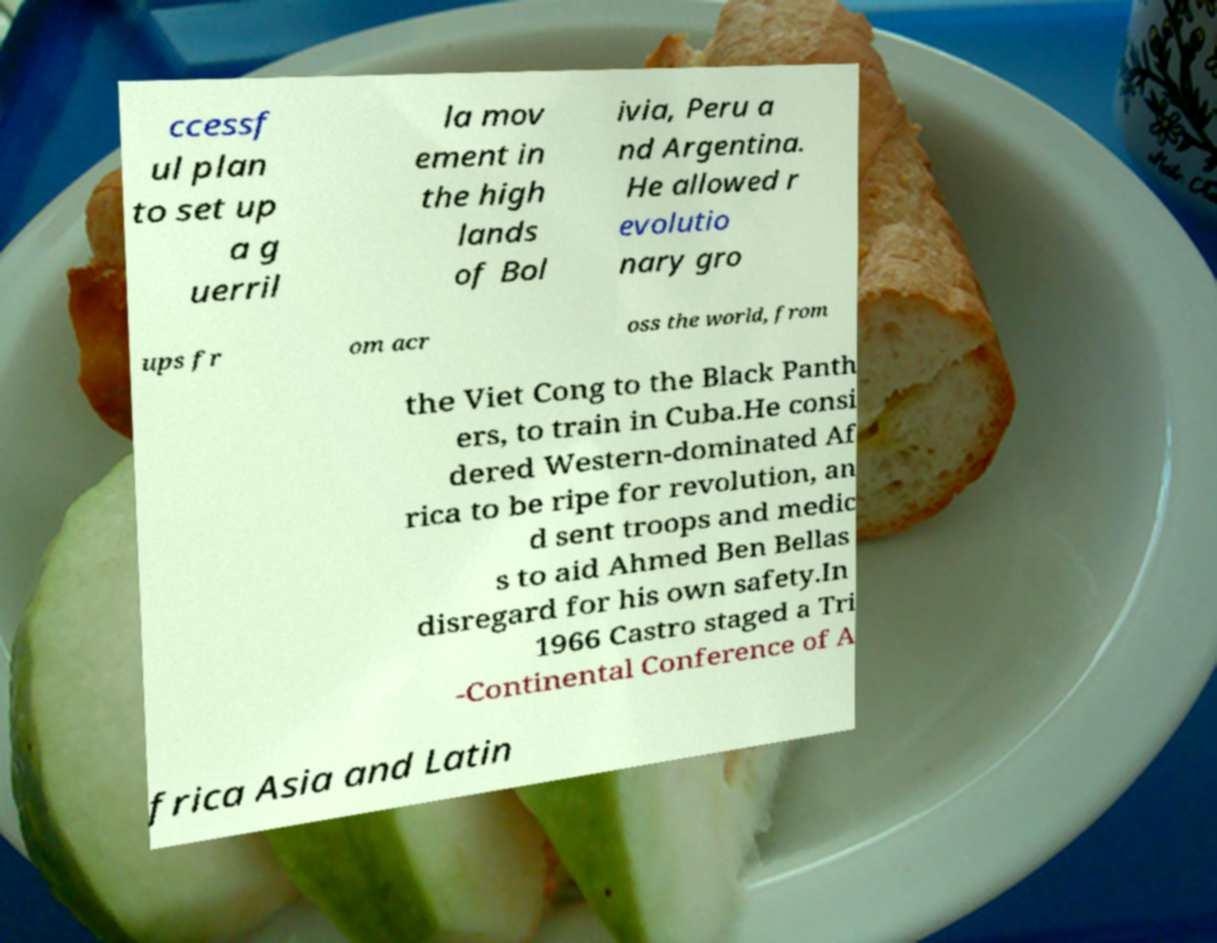Could you assist in decoding the text presented in this image and type it out clearly? ccessf ul plan to set up a g uerril la mov ement in the high lands of Bol ivia, Peru a nd Argentina. He allowed r evolutio nary gro ups fr om acr oss the world, from the Viet Cong to the Black Panth ers, to train in Cuba.He consi dered Western-dominated Af rica to be ripe for revolution, an d sent troops and medic s to aid Ahmed Ben Bellas disregard for his own safety.In 1966 Castro staged a Tri -Continental Conference of A frica Asia and Latin 